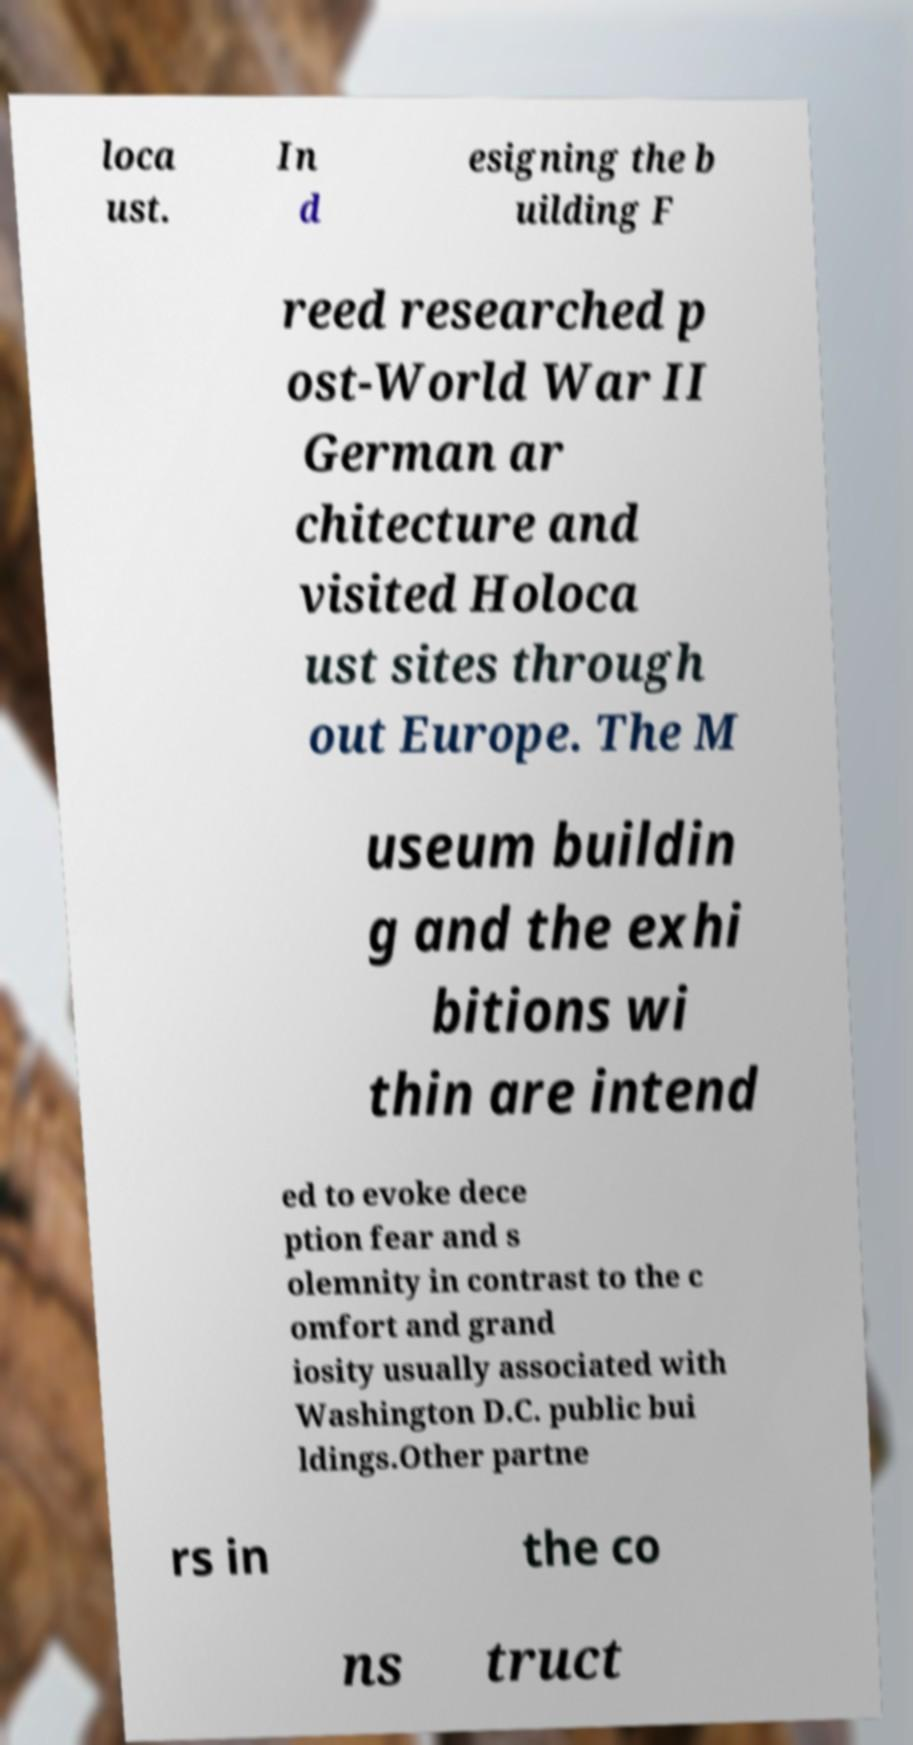Please identify and transcribe the text found in this image. loca ust. In d esigning the b uilding F reed researched p ost-World War II German ar chitecture and visited Holoca ust sites through out Europe. The M useum buildin g and the exhi bitions wi thin are intend ed to evoke dece ption fear and s olemnity in contrast to the c omfort and grand iosity usually associated with Washington D.C. public bui ldings.Other partne rs in the co ns truct 